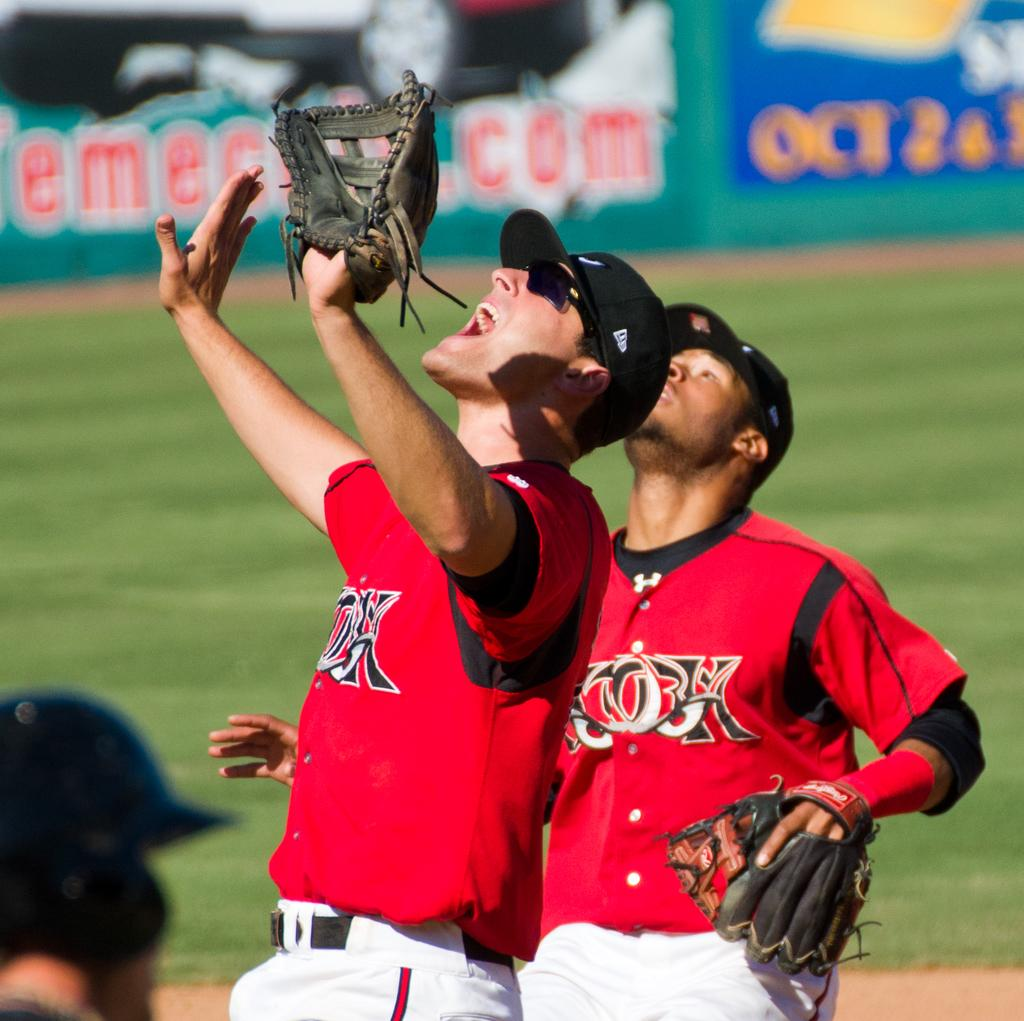<image>
Render a clear and concise summary of the photo. Two ball players look up in front of a blue sign that says OCT on it. 